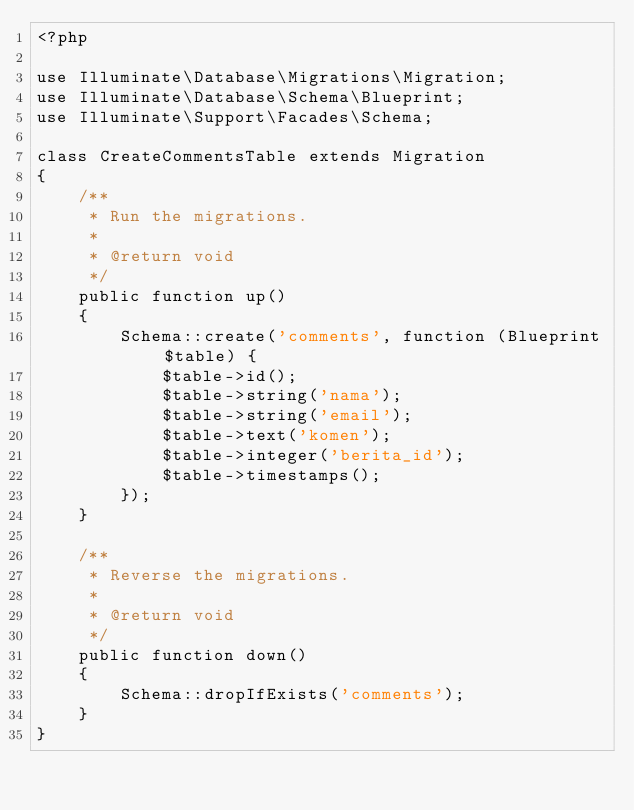Convert code to text. <code><loc_0><loc_0><loc_500><loc_500><_PHP_><?php

use Illuminate\Database\Migrations\Migration;
use Illuminate\Database\Schema\Blueprint;
use Illuminate\Support\Facades\Schema;

class CreateCommentsTable extends Migration
{
    /**
     * Run the migrations.
     *
     * @return void
     */
    public function up()
    {
        Schema::create('comments', function (Blueprint $table) {
            $table->id();
            $table->string('nama');
            $table->string('email');
            $table->text('komen');
            $table->integer('berita_id');
            $table->timestamps();
        });
    }

    /**
     * Reverse the migrations.
     *
     * @return void
     */
    public function down()
    {
        Schema::dropIfExists('comments');
    }
}
</code> 